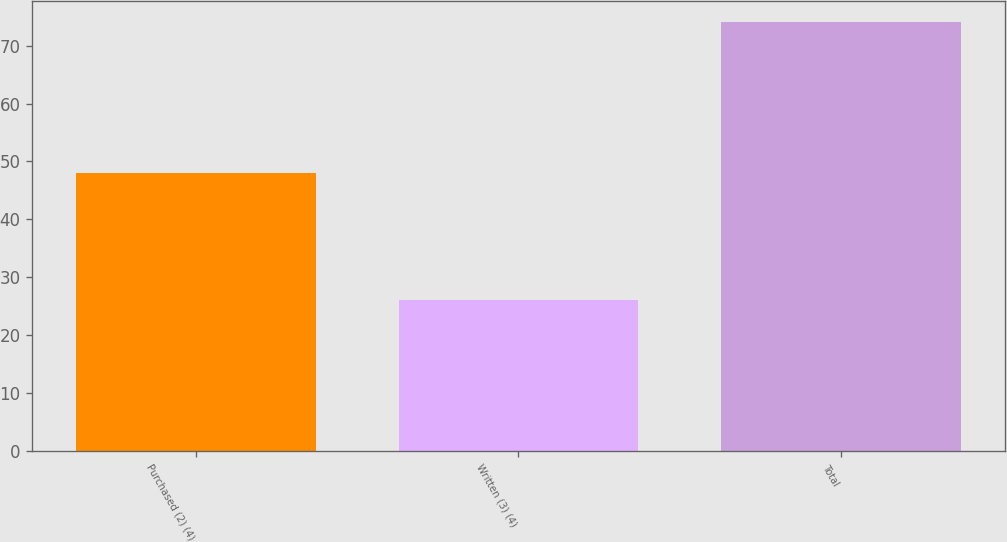Convert chart to OTSL. <chart><loc_0><loc_0><loc_500><loc_500><bar_chart><fcel>Purchased (2) (4)<fcel>Written (3) (4)<fcel>Total<nl><fcel>48<fcel>26<fcel>74<nl></chart> 